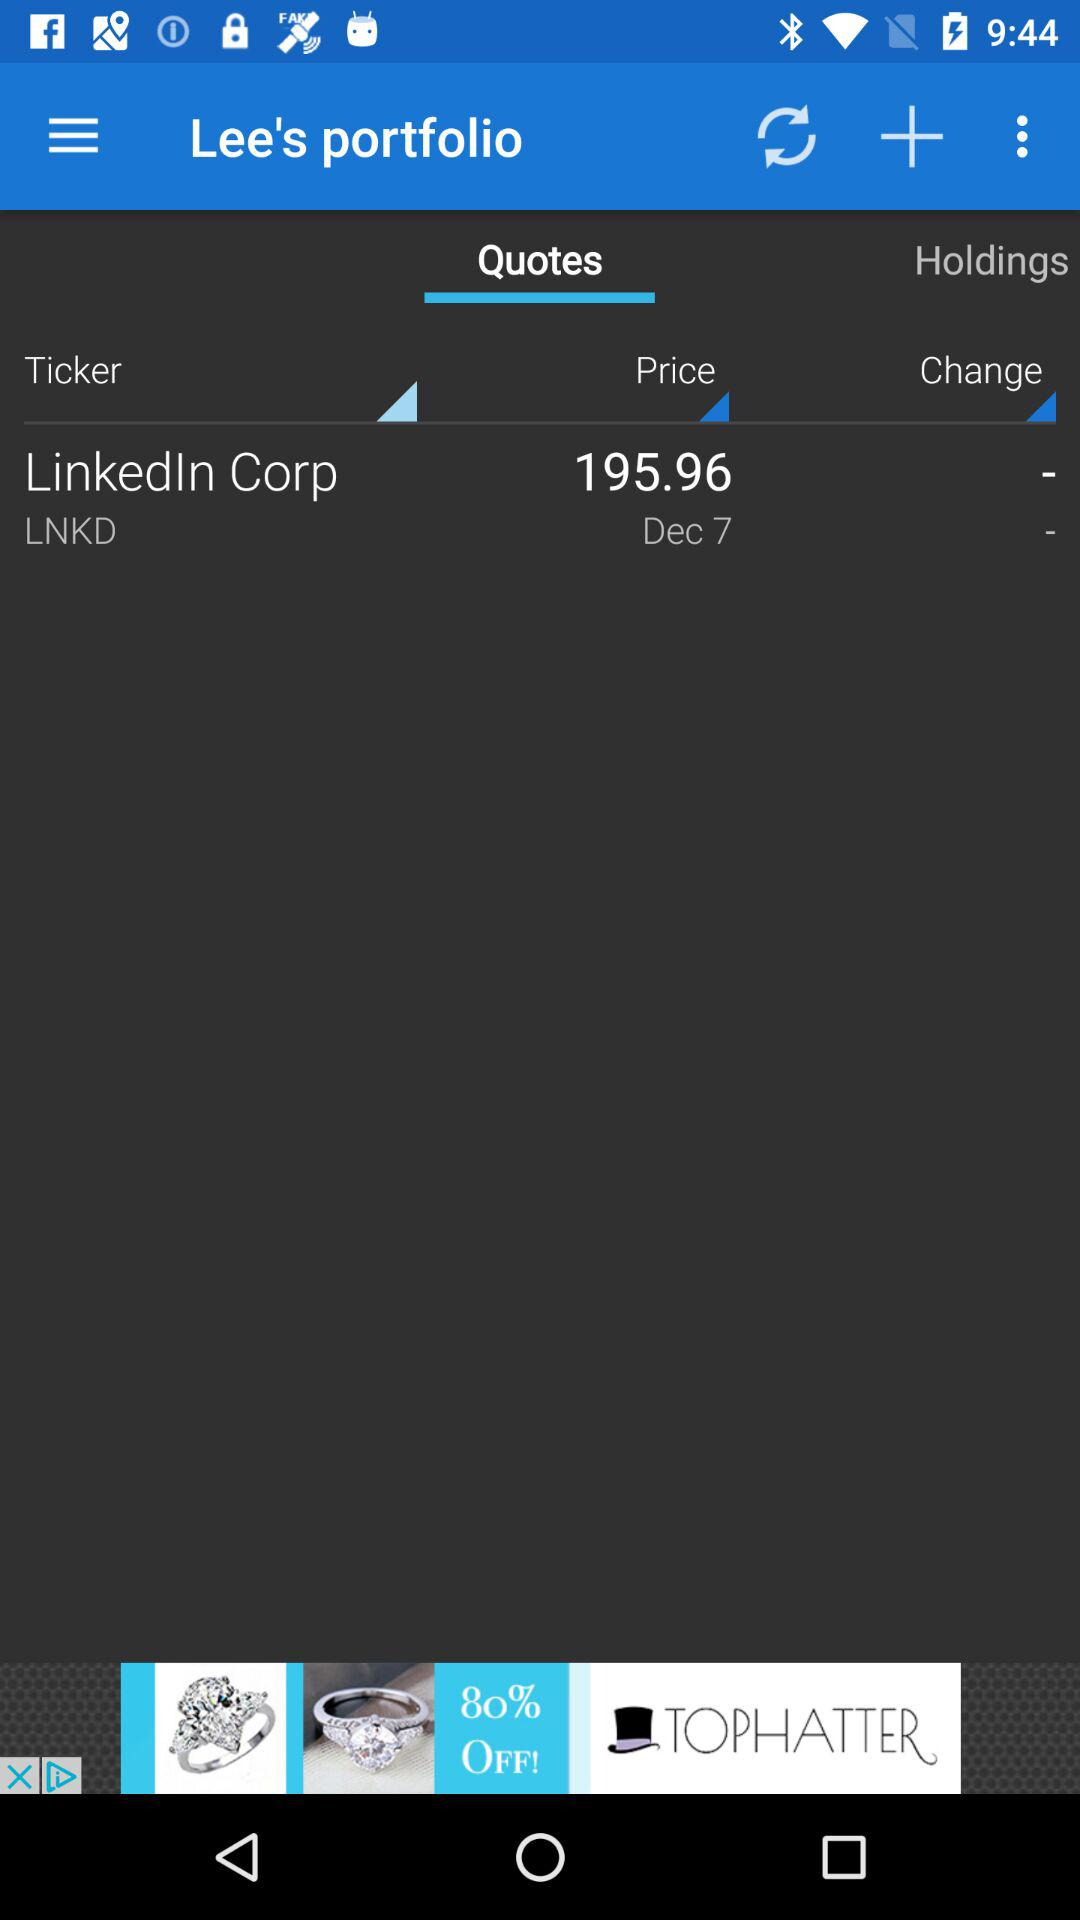Which tab is selected? The selected tab is "Quotes". 